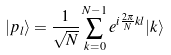Convert formula to latex. <formula><loc_0><loc_0><loc_500><loc_500>| p _ { l } \rangle = \frac { 1 } { \sqrt { N } } \sum _ { k = 0 } ^ { N - 1 } e ^ { i \frac { 2 \pi } { N } k l } | k \rangle</formula> 